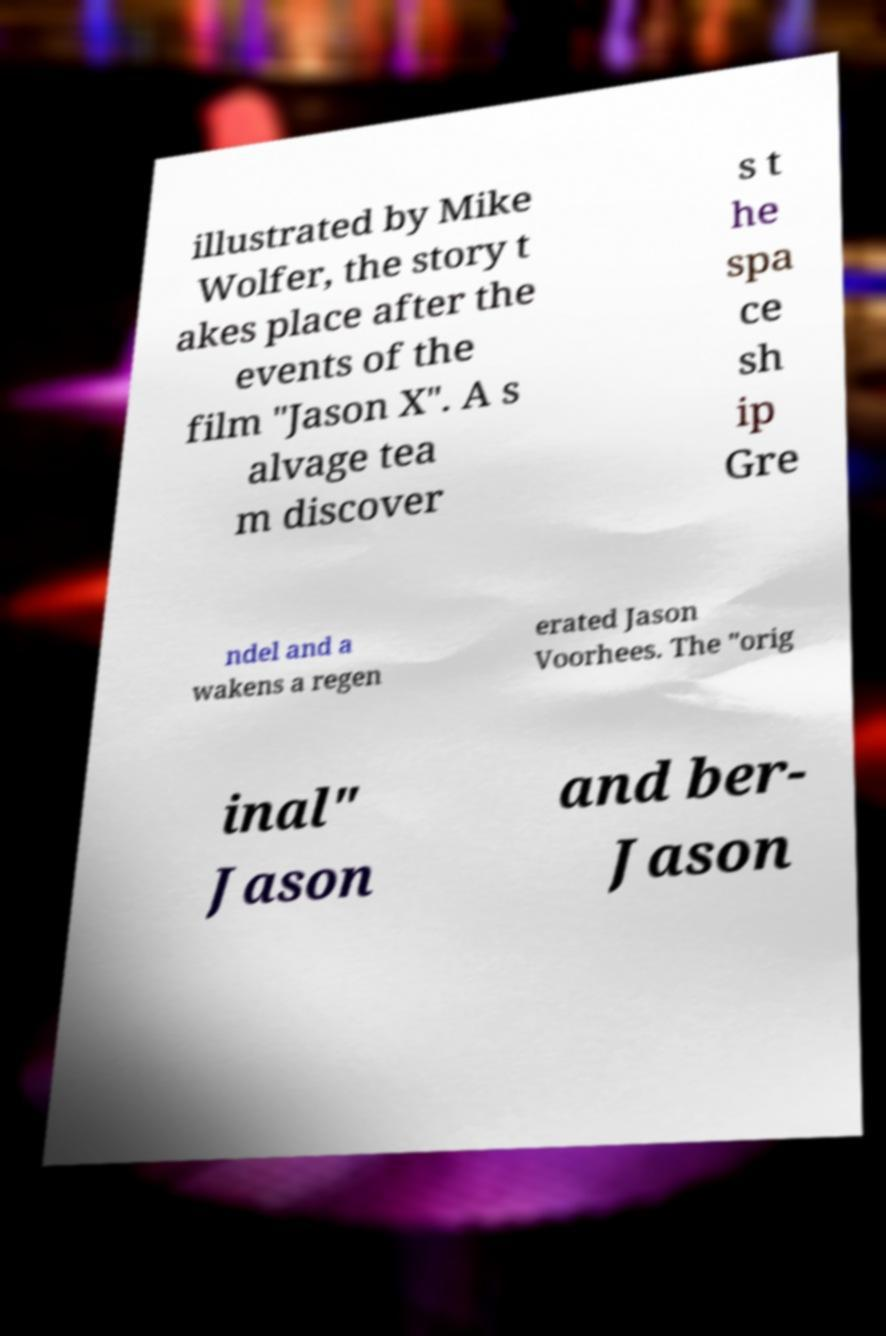I need the written content from this picture converted into text. Can you do that? illustrated by Mike Wolfer, the story t akes place after the events of the film "Jason X". A s alvage tea m discover s t he spa ce sh ip Gre ndel and a wakens a regen erated Jason Voorhees. The "orig inal" Jason and ber- Jason 